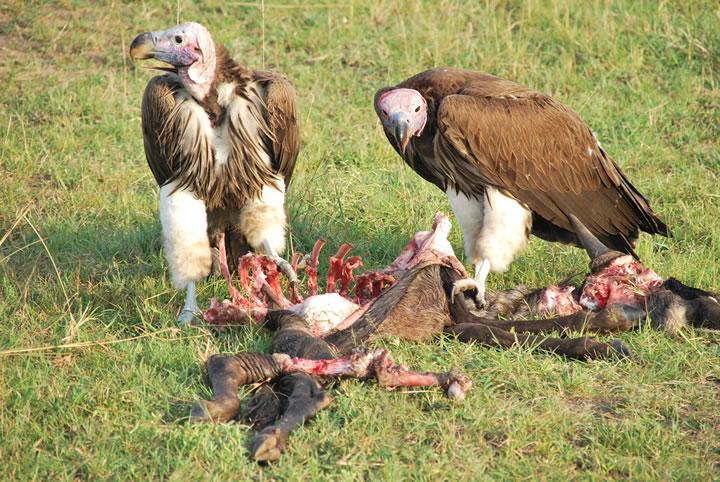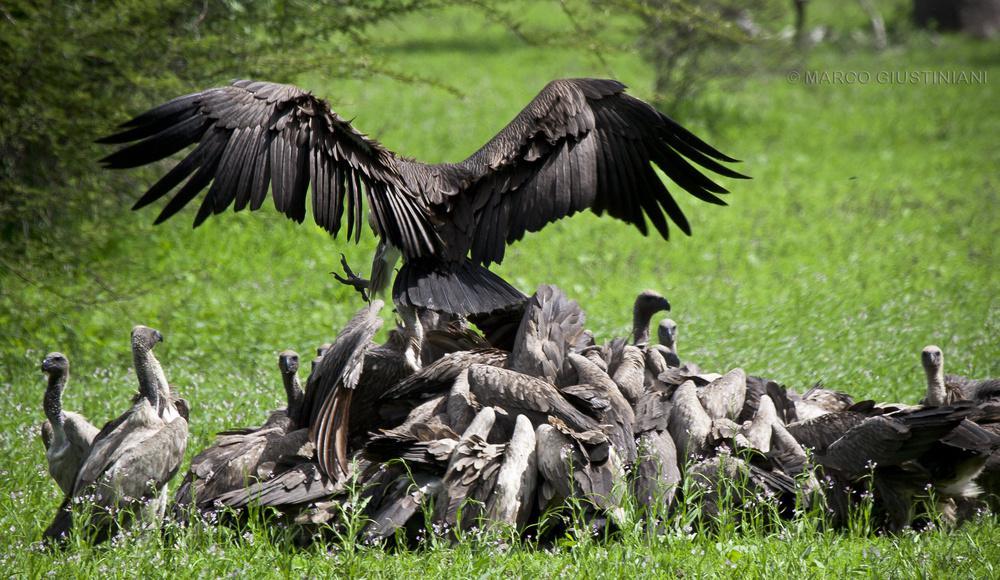The first image is the image on the left, the second image is the image on the right. Given the left and right images, does the statement "There is exactly one vulture and one eagle." hold true? Answer yes or no. No. The first image is the image on the left, the second image is the image on the right. Evaluate the accuracy of this statement regarding the images: "There are two vultures in the image pair". Is it true? Answer yes or no. No. 